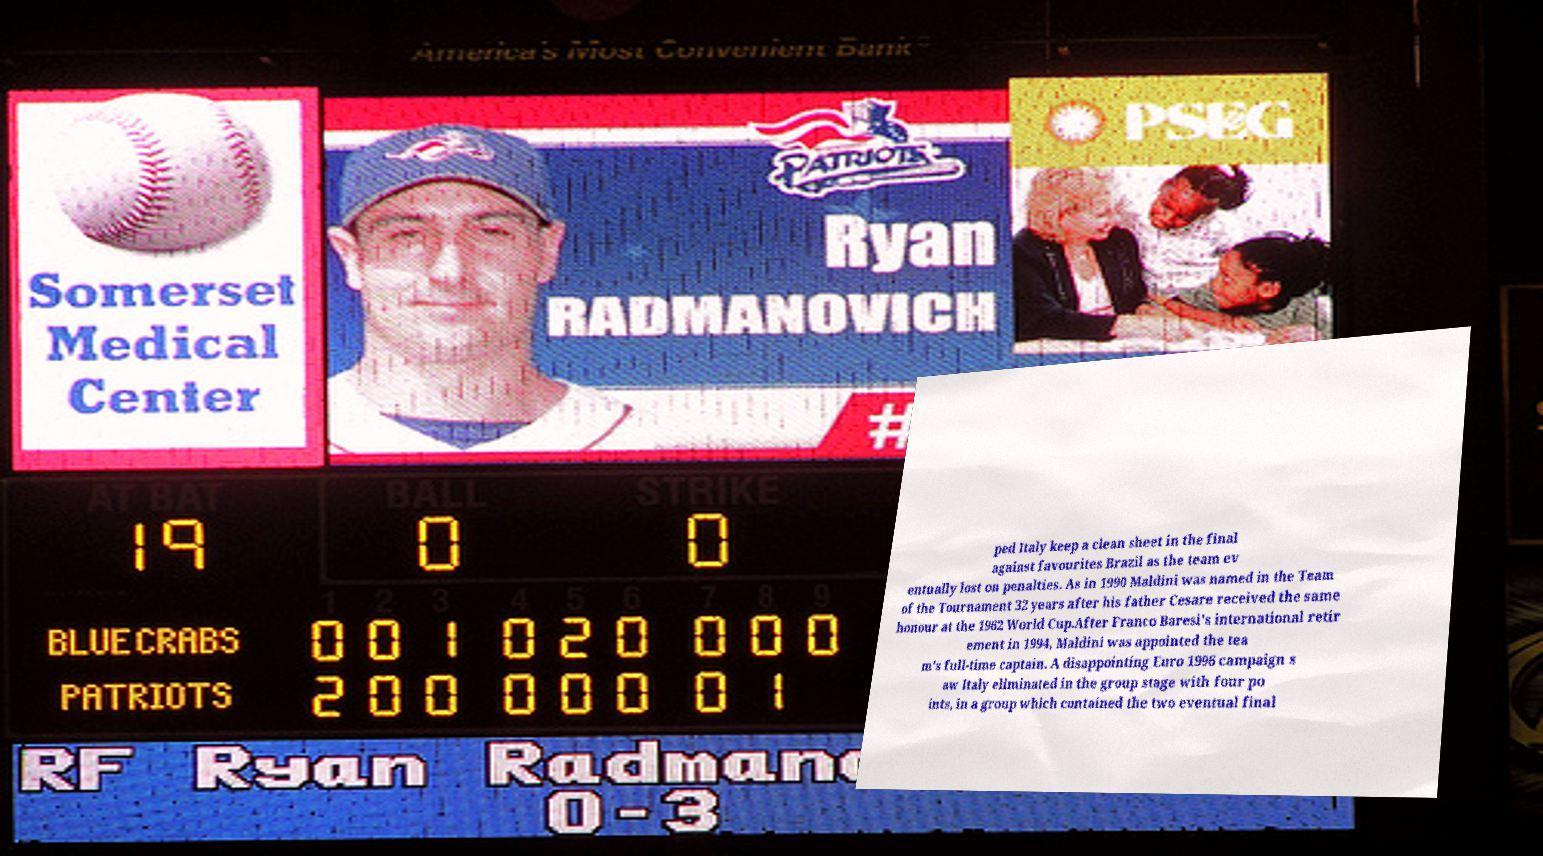There's text embedded in this image that I need extracted. Can you transcribe it verbatim? ped Italy keep a clean sheet in the final against favourites Brazil as the team ev entually lost on penalties. As in 1990 Maldini was named in the Team of the Tournament 32 years after his father Cesare received the same honour at the 1962 World Cup.After Franco Baresi's international retir ement in 1994, Maldini was appointed the tea m's full-time captain. A disappointing Euro 1996 campaign s aw Italy eliminated in the group stage with four po ints, in a group which contained the two eventual final 